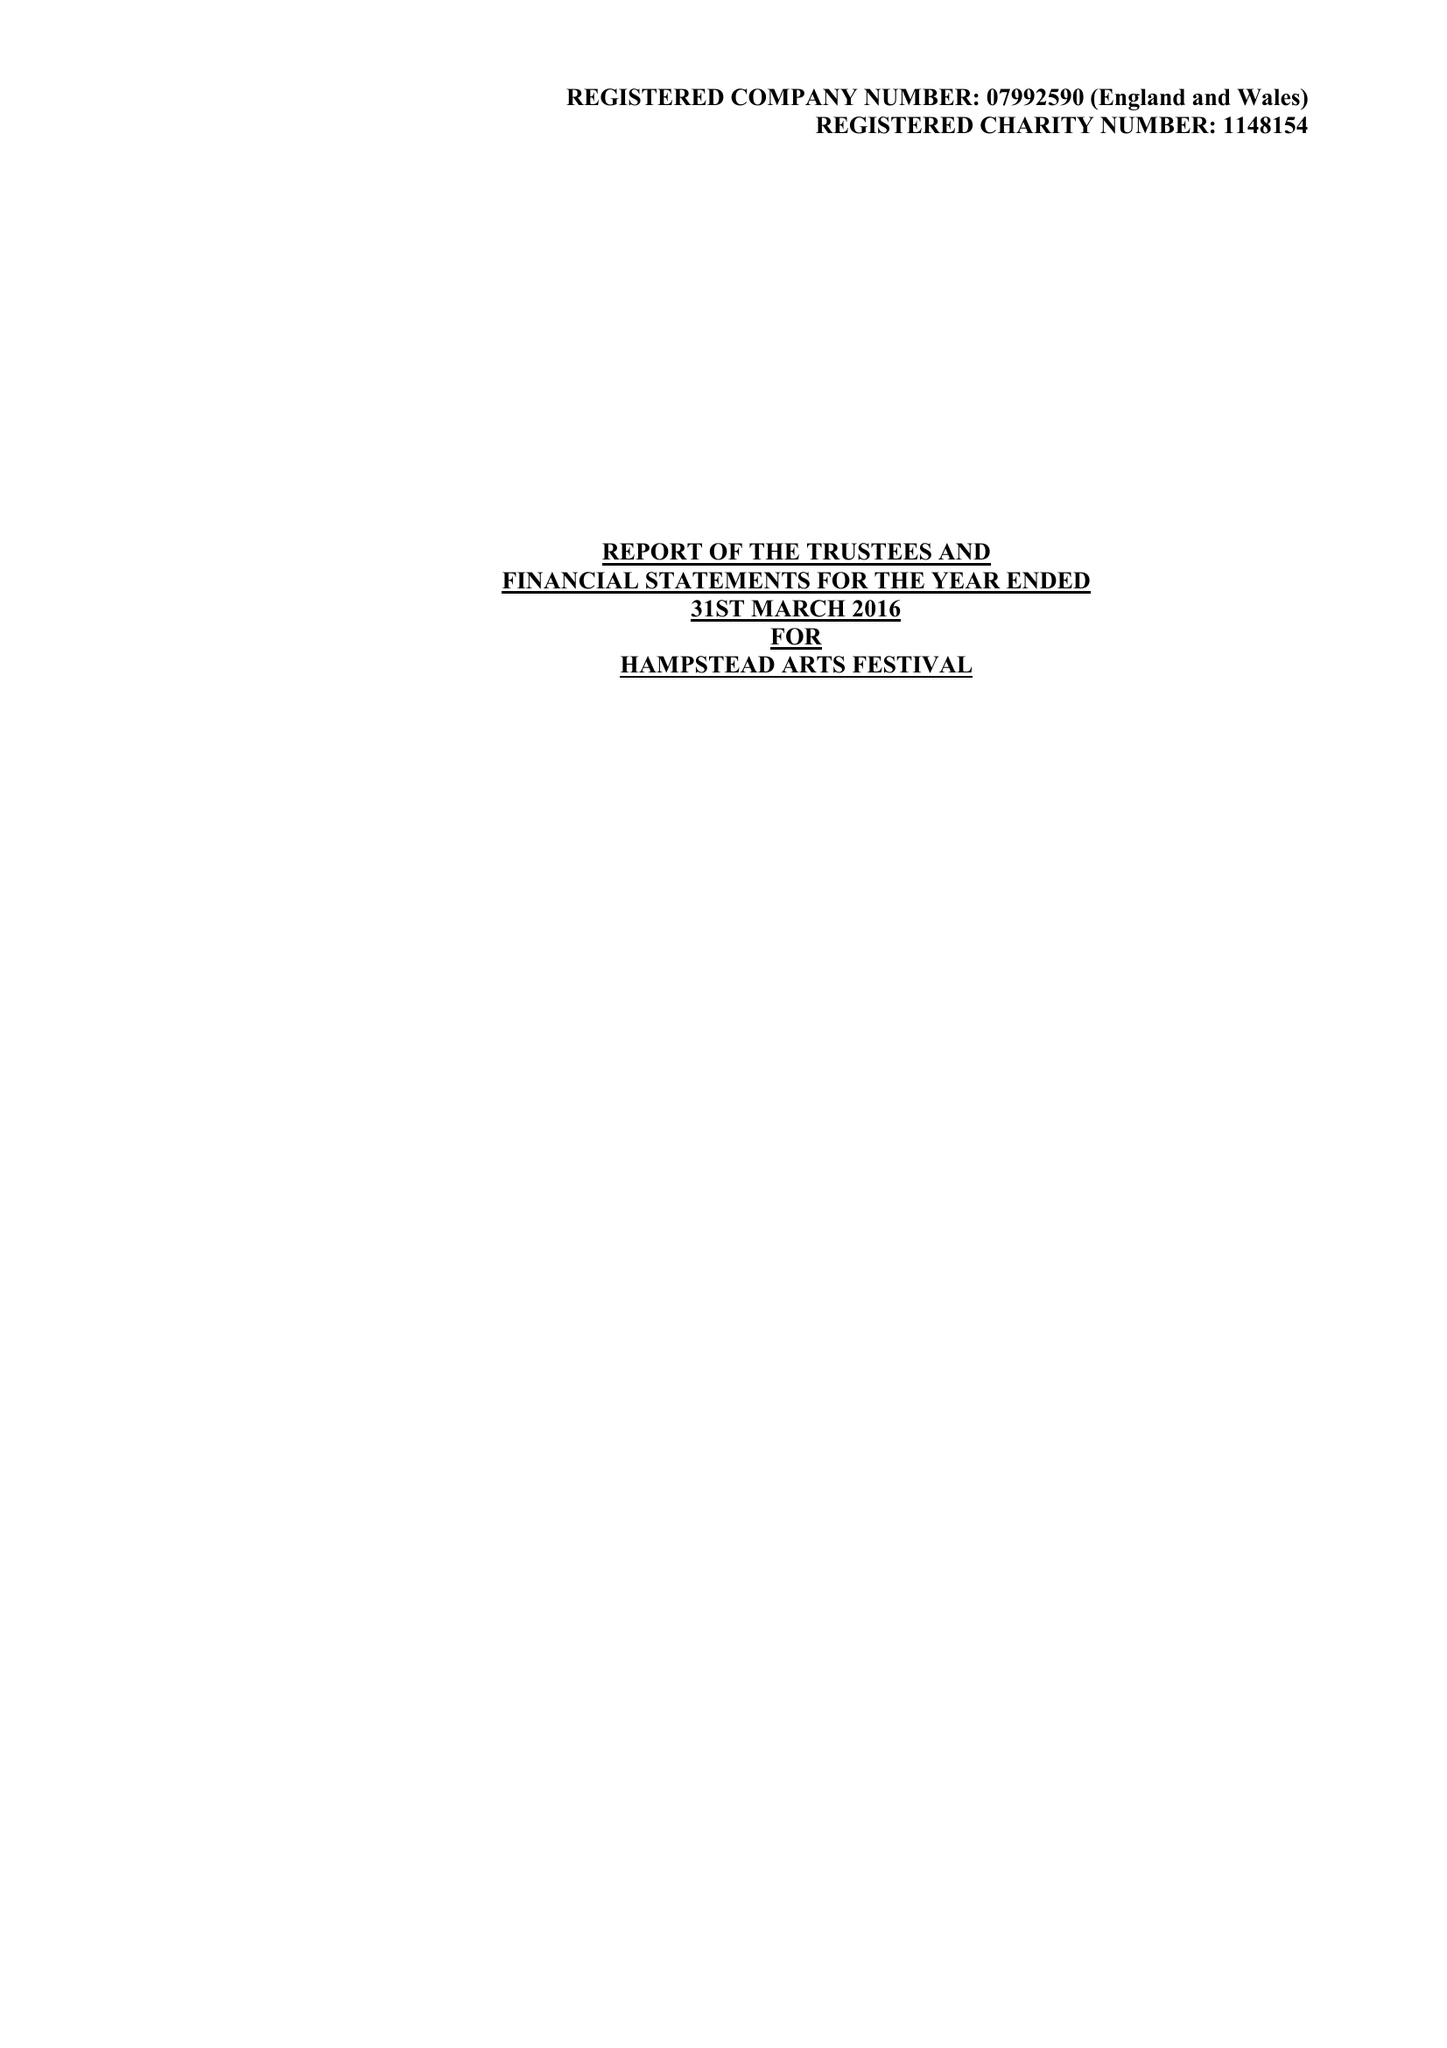What is the value for the address__postcode?
Answer the question using a single word or phrase. HA1 1EJ 